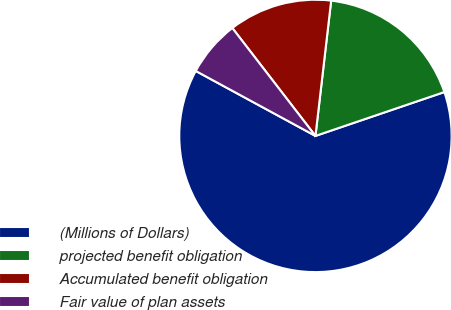Convert chart to OTSL. <chart><loc_0><loc_0><loc_500><loc_500><pie_chart><fcel>(Millions of Dollars)<fcel>projected benefit obligation<fcel>Accumulated benefit obligation<fcel>Fair value of plan assets<nl><fcel>63.14%<fcel>17.94%<fcel>12.29%<fcel>6.64%<nl></chart> 